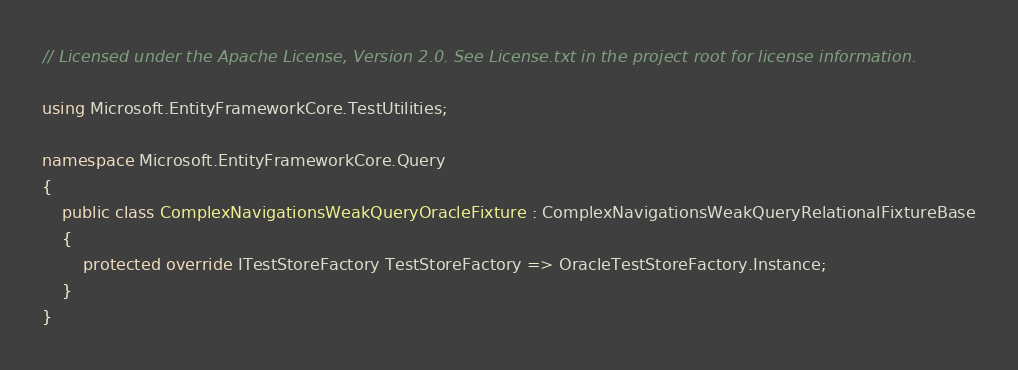<code> <loc_0><loc_0><loc_500><loc_500><_C#_>// Licensed under the Apache License, Version 2.0. See License.txt in the project root for license information.

using Microsoft.EntityFrameworkCore.TestUtilities;

namespace Microsoft.EntityFrameworkCore.Query
{
    public class ComplexNavigationsWeakQueryOracleFixture : ComplexNavigationsWeakQueryRelationalFixtureBase
    {
        protected override ITestStoreFactory TestStoreFactory => OracleTestStoreFactory.Instance;
    }
}
</code> 